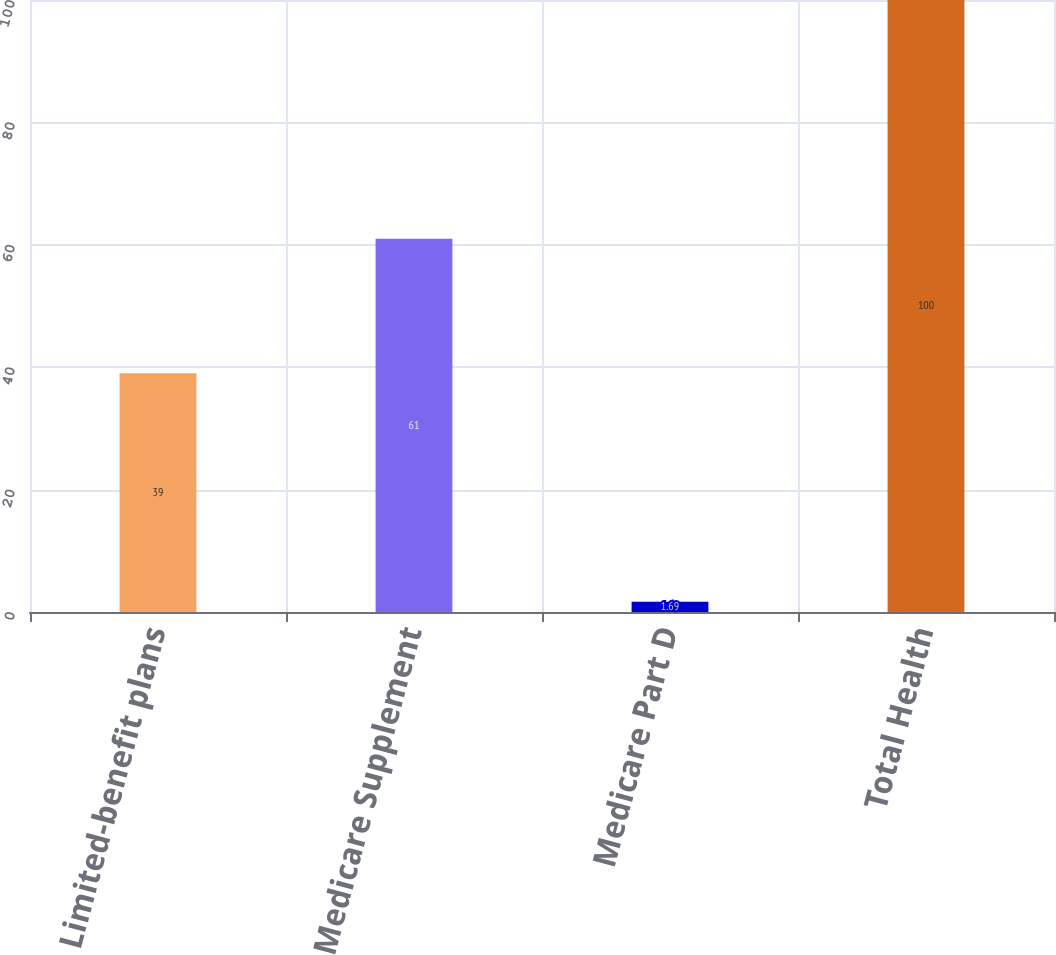Convert chart. <chart><loc_0><loc_0><loc_500><loc_500><bar_chart><fcel>Limited-benefit plans<fcel>Medicare Supplement<fcel>Medicare Part D<fcel>Total Health<nl><fcel>39<fcel>61<fcel>1.69<fcel>100<nl></chart> 